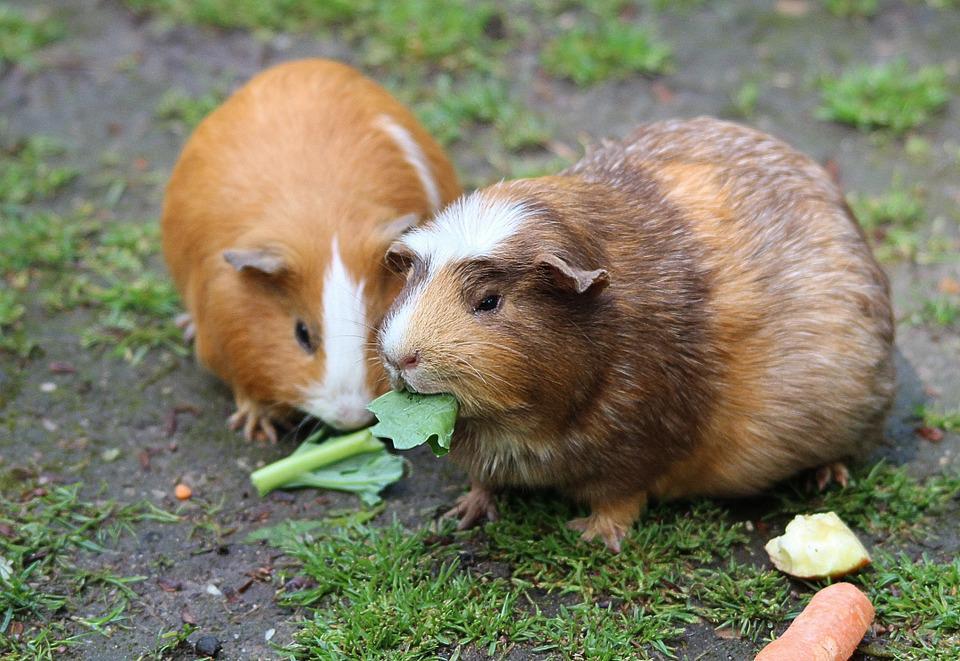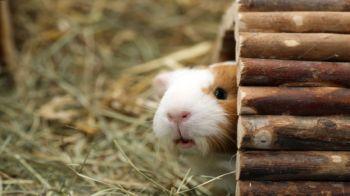The first image is the image on the left, the second image is the image on the right. Given the left and right images, does the statement "There is one animal in the image on the left." hold true? Answer yes or no. No. 